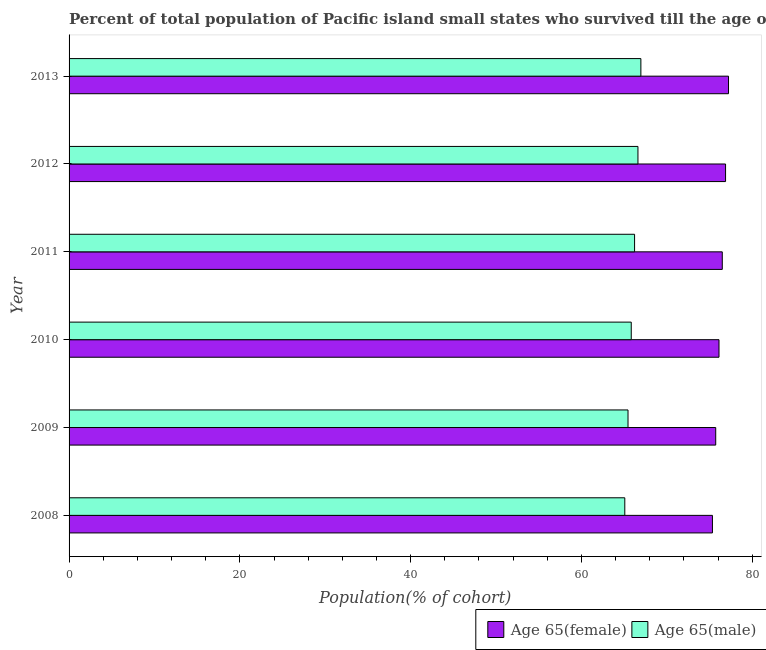Are the number of bars on each tick of the Y-axis equal?
Make the answer very short. Yes. How many bars are there on the 6th tick from the top?
Give a very brief answer. 2. What is the label of the 2nd group of bars from the top?
Offer a terse response. 2012. What is the percentage of female population who survived till age of 65 in 2009?
Your answer should be compact. 75.72. Across all years, what is the maximum percentage of female population who survived till age of 65?
Your response must be concise. 77.22. Across all years, what is the minimum percentage of male population who survived till age of 65?
Offer a very short reply. 65.07. In which year was the percentage of male population who survived till age of 65 minimum?
Make the answer very short. 2008. What is the total percentage of male population who survived till age of 65 in the graph?
Your answer should be very brief. 396.15. What is the difference between the percentage of female population who survived till age of 65 in 2012 and that in 2013?
Offer a terse response. -0.35. What is the difference between the percentage of male population who survived till age of 65 in 2009 and the percentage of female population who survived till age of 65 in 2011?
Make the answer very short. -11.04. What is the average percentage of female population who survived till age of 65 per year?
Provide a succinct answer. 76.29. In the year 2013, what is the difference between the percentage of male population who survived till age of 65 and percentage of female population who survived till age of 65?
Offer a very short reply. -10.26. Is the percentage of female population who survived till age of 65 in 2010 less than that in 2011?
Offer a very short reply. Yes. Is the difference between the percentage of male population who survived till age of 65 in 2011 and 2012 greater than the difference between the percentage of female population who survived till age of 65 in 2011 and 2012?
Offer a terse response. No. What is the difference between the highest and the second highest percentage of male population who survived till age of 65?
Your response must be concise. 0.34. What is the difference between the highest and the lowest percentage of female population who survived till age of 65?
Ensure brevity in your answer.  1.88. Is the sum of the percentage of male population who survived till age of 65 in 2012 and 2013 greater than the maximum percentage of female population who survived till age of 65 across all years?
Provide a succinct answer. Yes. What does the 1st bar from the top in 2010 represents?
Offer a terse response. Age 65(male). What does the 1st bar from the bottom in 2011 represents?
Offer a very short reply. Age 65(female). Are all the bars in the graph horizontal?
Provide a short and direct response. Yes. What is the difference between two consecutive major ticks on the X-axis?
Your answer should be compact. 20. Does the graph contain grids?
Offer a terse response. No. How are the legend labels stacked?
Provide a short and direct response. Horizontal. What is the title of the graph?
Ensure brevity in your answer.  Percent of total population of Pacific island small states who survived till the age of 65 years. What is the label or title of the X-axis?
Give a very brief answer. Population(% of cohort). What is the label or title of the Y-axis?
Ensure brevity in your answer.  Year. What is the Population(% of cohort) of Age 65(female) in 2008?
Ensure brevity in your answer.  75.34. What is the Population(% of cohort) in Age 65(male) in 2008?
Ensure brevity in your answer.  65.07. What is the Population(% of cohort) in Age 65(female) in 2009?
Make the answer very short. 75.72. What is the Population(% of cohort) in Age 65(male) in 2009?
Offer a terse response. 65.45. What is the Population(% of cohort) of Age 65(female) in 2010?
Keep it short and to the point. 76.11. What is the Population(% of cohort) in Age 65(male) in 2010?
Your response must be concise. 65.83. What is the Population(% of cohort) of Age 65(female) in 2011?
Provide a succinct answer. 76.49. What is the Population(% of cohort) of Age 65(male) in 2011?
Ensure brevity in your answer.  66.22. What is the Population(% of cohort) in Age 65(female) in 2012?
Your answer should be very brief. 76.87. What is the Population(% of cohort) in Age 65(male) in 2012?
Provide a succinct answer. 66.62. What is the Population(% of cohort) in Age 65(female) in 2013?
Your answer should be compact. 77.22. What is the Population(% of cohort) of Age 65(male) in 2013?
Your response must be concise. 66.96. Across all years, what is the maximum Population(% of cohort) of Age 65(female)?
Keep it short and to the point. 77.22. Across all years, what is the maximum Population(% of cohort) in Age 65(male)?
Your answer should be very brief. 66.96. Across all years, what is the minimum Population(% of cohort) in Age 65(female)?
Your answer should be very brief. 75.34. Across all years, what is the minimum Population(% of cohort) of Age 65(male)?
Ensure brevity in your answer.  65.07. What is the total Population(% of cohort) in Age 65(female) in the graph?
Your answer should be compact. 457.75. What is the total Population(% of cohort) in Age 65(male) in the graph?
Your answer should be very brief. 396.15. What is the difference between the Population(% of cohort) in Age 65(female) in 2008 and that in 2009?
Your answer should be very brief. -0.38. What is the difference between the Population(% of cohort) of Age 65(male) in 2008 and that in 2009?
Give a very brief answer. -0.38. What is the difference between the Population(% of cohort) in Age 65(female) in 2008 and that in 2010?
Keep it short and to the point. -0.77. What is the difference between the Population(% of cohort) in Age 65(male) in 2008 and that in 2010?
Your response must be concise. -0.76. What is the difference between the Population(% of cohort) of Age 65(female) in 2008 and that in 2011?
Make the answer very short. -1.15. What is the difference between the Population(% of cohort) of Age 65(male) in 2008 and that in 2011?
Ensure brevity in your answer.  -1.15. What is the difference between the Population(% of cohort) in Age 65(female) in 2008 and that in 2012?
Keep it short and to the point. -1.54. What is the difference between the Population(% of cohort) of Age 65(male) in 2008 and that in 2012?
Give a very brief answer. -1.54. What is the difference between the Population(% of cohort) in Age 65(female) in 2008 and that in 2013?
Your response must be concise. -1.88. What is the difference between the Population(% of cohort) of Age 65(male) in 2008 and that in 2013?
Offer a terse response. -1.88. What is the difference between the Population(% of cohort) of Age 65(female) in 2009 and that in 2010?
Give a very brief answer. -0.38. What is the difference between the Population(% of cohort) of Age 65(male) in 2009 and that in 2010?
Give a very brief answer. -0.38. What is the difference between the Population(% of cohort) in Age 65(female) in 2009 and that in 2011?
Provide a succinct answer. -0.77. What is the difference between the Population(% of cohort) in Age 65(male) in 2009 and that in 2011?
Give a very brief answer. -0.77. What is the difference between the Population(% of cohort) in Age 65(female) in 2009 and that in 2012?
Your response must be concise. -1.15. What is the difference between the Population(% of cohort) of Age 65(male) in 2009 and that in 2012?
Offer a very short reply. -1.17. What is the difference between the Population(% of cohort) in Age 65(female) in 2009 and that in 2013?
Your response must be concise. -1.5. What is the difference between the Population(% of cohort) of Age 65(male) in 2009 and that in 2013?
Provide a succinct answer. -1.51. What is the difference between the Population(% of cohort) in Age 65(female) in 2010 and that in 2011?
Provide a short and direct response. -0.38. What is the difference between the Population(% of cohort) in Age 65(male) in 2010 and that in 2011?
Offer a terse response. -0.39. What is the difference between the Population(% of cohort) of Age 65(female) in 2010 and that in 2012?
Provide a short and direct response. -0.77. What is the difference between the Population(% of cohort) of Age 65(male) in 2010 and that in 2012?
Provide a succinct answer. -0.79. What is the difference between the Population(% of cohort) in Age 65(female) in 2010 and that in 2013?
Keep it short and to the point. -1.11. What is the difference between the Population(% of cohort) in Age 65(male) in 2010 and that in 2013?
Your response must be concise. -1.13. What is the difference between the Population(% of cohort) of Age 65(female) in 2011 and that in 2012?
Offer a very short reply. -0.38. What is the difference between the Population(% of cohort) of Age 65(male) in 2011 and that in 2012?
Provide a short and direct response. -0.4. What is the difference between the Population(% of cohort) of Age 65(female) in 2011 and that in 2013?
Make the answer very short. -0.73. What is the difference between the Population(% of cohort) of Age 65(male) in 2011 and that in 2013?
Make the answer very short. -0.74. What is the difference between the Population(% of cohort) of Age 65(female) in 2012 and that in 2013?
Your response must be concise. -0.35. What is the difference between the Population(% of cohort) in Age 65(male) in 2012 and that in 2013?
Your answer should be very brief. -0.34. What is the difference between the Population(% of cohort) in Age 65(female) in 2008 and the Population(% of cohort) in Age 65(male) in 2009?
Your answer should be compact. 9.89. What is the difference between the Population(% of cohort) in Age 65(female) in 2008 and the Population(% of cohort) in Age 65(male) in 2010?
Your response must be concise. 9.51. What is the difference between the Population(% of cohort) in Age 65(female) in 2008 and the Population(% of cohort) in Age 65(male) in 2011?
Offer a terse response. 9.12. What is the difference between the Population(% of cohort) of Age 65(female) in 2008 and the Population(% of cohort) of Age 65(male) in 2012?
Your answer should be compact. 8.72. What is the difference between the Population(% of cohort) in Age 65(female) in 2008 and the Population(% of cohort) in Age 65(male) in 2013?
Keep it short and to the point. 8.38. What is the difference between the Population(% of cohort) in Age 65(female) in 2009 and the Population(% of cohort) in Age 65(male) in 2010?
Your answer should be compact. 9.89. What is the difference between the Population(% of cohort) in Age 65(female) in 2009 and the Population(% of cohort) in Age 65(male) in 2011?
Offer a very short reply. 9.5. What is the difference between the Population(% of cohort) of Age 65(female) in 2009 and the Population(% of cohort) of Age 65(male) in 2012?
Give a very brief answer. 9.11. What is the difference between the Population(% of cohort) of Age 65(female) in 2009 and the Population(% of cohort) of Age 65(male) in 2013?
Keep it short and to the point. 8.76. What is the difference between the Population(% of cohort) in Age 65(female) in 2010 and the Population(% of cohort) in Age 65(male) in 2011?
Provide a short and direct response. 9.89. What is the difference between the Population(% of cohort) of Age 65(female) in 2010 and the Population(% of cohort) of Age 65(male) in 2012?
Offer a very short reply. 9.49. What is the difference between the Population(% of cohort) in Age 65(female) in 2010 and the Population(% of cohort) in Age 65(male) in 2013?
Your answer should be very brief. 9.15. What is the difference between the Population(% of cohort) of Age 65(female) in 2011 and the Population(% of cohort) of Age 65(male) in 2012?
Provide a short and direct response. 9.87. What is the difference between the Population(% of cohort) in Age 65(female) in 2011 and the Population(% of cohort) in Age 65(male) in 2013?
Make the answer very short. 9.53. What is the difference between the Population(% of cohort) of Age 65(female) in 2012 and the Population(% of cohort) of Age 65(male) in 2013?
Offer a very short reply. 9.92. What is the average Population(% of cohort) in Age 65(female) per year?
Your answer should be compact. 76.29. What is the average Population(% of cohort) of Age 65(male) per year?
Offer a terse response. 66.03. In the year 2008, what is the difference between the Population(% of cohort) in Age 65(female) and Population(% of cohort) in Age 65(male)?
Ensure brevity in your answer.  10.26. In the year 2009, what is the difference between the Population(% of cohort) in Age 65(female) and Population(% of cohort) in Age 65(male)?
Keep it short and to the point. 10.27. In the year 2010, what is the difference between the Population(% of cohort) of Age 65(female) and Population(% of cohort) of Age 65(male)?
Your answer should be very brief. 10.28. In the year 2011, what is the difference between the Population(% of cohort) of Age 65(female) and Population(% of cohort) of Age 65(male)?
Provide a succinct answer. 10.27. In the year 2012, what is the difference between the Population(% of cohort) in Age 65(female) and Population(% of cohort) in Age 65(male)?
Offer a terse response. 10.26. In the year 2013, what is the difference between the Population(% of cohort) of Age 65(female) and Population(% of cohort) of Age 65(male)?
Your answer should be very brief. 10.26. What is the ratio of the Population(% of cohort) of Age 65(female) in 2008 to that in 2009?
Your answer should be compact. 0.99. What is the ratio of the Population(% of cohort) of Age 65(male) in 2008 to that in 2009?
Offer a terse response. 0.99. What is the ratio of the Population(% of cohort) of Age 65(female) in 2008 to that in 2010?
Ensure brevity in your answer.  0.99. What is the ratio of the Population(% of cohort) of Age 65(male) in 2008 to that in 2010?
Your answer should be compact. 0.99. What is the ratio of the Population(% of cohort) in Age 65(female) in 2008 to that in 2011?
Offer a terse response. 0.98. What is the ratio of the Population(% of cohort) in Age 65(male) in 2008 to that in 2011?
Offer a terse response. 0.98. What is the ratio of the Population(% of cohort) in Age 65(female) in 2008 to that in 2012?
Offer a terse response. 0.98. What is the ratio of the Population(% of cohort) of Age 65(male) in 2008 to that in 2012?
Make the answer very short. 0.98. What is the ratio of the Population(% of cohort) in Age 65(female) in 2008 to that in 2013?
Ensure brevity in your answer.  0.98. What is the ratio of the Population(% of cohort) in Age 65(male) in 2008 to that in 2013?
Ensure brevity in your answer.  0.97. What is the ratio of the Population(% of cohort) of Age 65(male) in 2009 to that in 2010?
Your answer should be compact. 0.99. What is the ratio of the Population(% of cohort) of Age 65(female) in 2009 to that in 2011?
Provide a succinct answer. 0.99. What is the ratio of the Population(% of cohort) in Age 65(male) in 2009 to that in 2011?
Make the answer very short. 0.99. What is the ratio of the Population(% of cohort) in Age 65(female) in 2009 to that in 2012?
Provide a succinct answer. 0.98. What is the ratio of the Population(% of cohort) in Age 65(male) in 2009 to that in 2012?
Make the answer very short. 0.98. What is the ratio of the Population(% of cohort) in Age 65(female) in 2009 to that in 2013?
Give a very brief answer. 0.98. What is the ratio of the Population(% of cohort) of Age 65(male) in 2009 to that in 2013?
Your answer should be very brief. 0.98. What is the ratio of the Population(% of cohort) in Age 65(female) in 2010 to that in 2013?
Provide a short and direct response. 0.99. What is the ratio of the Population(% of cohort) of Age 65(male) in 2010 to that in 2013?
Your answer should be very brief. 0.98. What is the ratio of the Population(% of cohort) in Age 65(female) in 2011 to that in 2013?
Give a very brief answer. 0.99. What is the ratio of the Population(% of cohort) of Age 65(male) in 2012 to that in 2013?
Make the answer very short. 0.99. What is the difference between the highest and the second highest Population(% of cohort) in Age 65(female)?
Give a very brief answer. 0.35. What is the difference between the highest and the second highest Population(% of cohort) in Age 65(male)?
Keep it short and to the point. 0.34. What is the difference between the highest and the lowest Population(% of cohort) of Age 65(female)?
Ensure brevity in your answer.  1.88. What is the difference between the highest and the lowest Population(% of cohort) of Age 65(male)?
Make the answer very short. 1.88. 